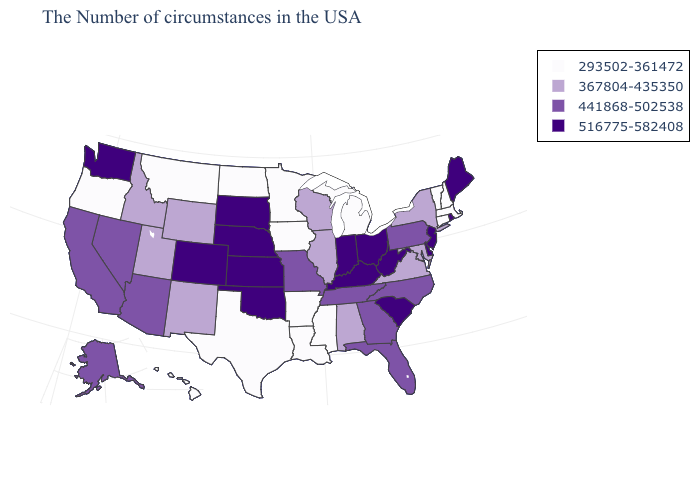What is the highest value in the USA?
Write a very short answer. 516775-582408. What is the value of New York?
Give a very brief answer. 367804-435350. Does California have the highest value in the West?
Be succinct. No. Does Connecticut have the highest value in the Northeast?
Be succinct. No. Does Utah have the same value as Maryland?
Give a very brief answer. Yes. What is the highest value in the South ?
Be succinct. 516775-582408. Among the states that border Kansas , which have the lowest value?
Give a very brief answer. Missouri. What is the value of Vermont?
Write a very short answer. 293502-361472. What is the lowest value in states that border Connecticut?
Short answer required. 293502-361472. What is the value of Nevada?
Be succinct. 441868-502538. Name the states that have a value in the range 441868-502538?
Short answer required. Pennsylvania, North Carolina, Florida, Georgia, Tennessee, Missouri, Arizona, Nevada, California, Alaska. Name the states that have a value in the range 367804-435350?
Answer briefly. New York, Maryland, Virginia, Alabama, Wisconsin, Illinois, Wyoming, New Mexico, Utah, Idaho. Does Louisiana have a lower value than South Dakota?
Keep it brief. Yes. What is the value of Utah?
Quick response, please. 367804-435350. Name the states that have a value in the range 293502-361472?
Short answer required. Massachusetts, New Hampshire, Vermont, Connecticut, Michigan, Mississippi, Louisiana, Arkansas, Minnesota, Iowa, Texas, North Dakota, Montana, Oregon, Hawaii. 